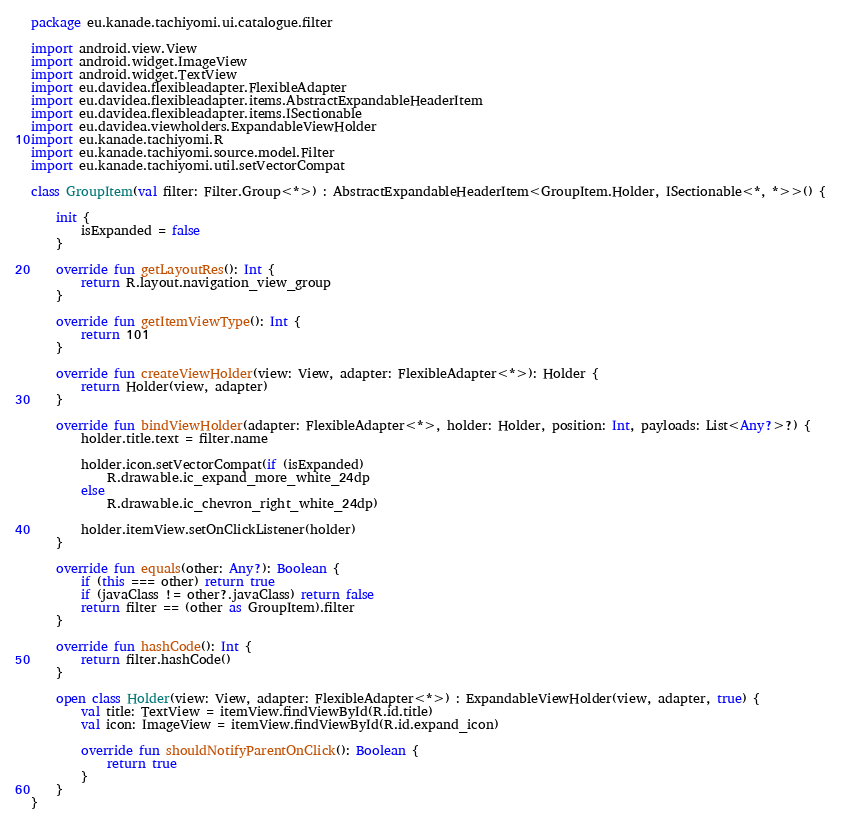<code> <loc_0><loc_0><loc_500><loc_500><_Kotlin_>package eu.kanade.tachiyomi.ui.catalogue.filter

import android.view.View
import android.widget.ImageView
import android.widget.TextView
import eu.davidea.flexibleadapter.FlexibleAdapter
import eu.davidea.flexibleadapter.items.AbstractExpandableHeaderItem
import eu.davidea.flexibleadapter.items.ISectionable
import eu.davidea.viewholders.ExpandableViewHolder
import eu.kanade.tachiyomi.R
import eu.kanade.tachiyomi.source.model.Filter
import eu.kanade.tachiyomi.util.setVectorCompat

class GroupItem(val filter: Filter.Group<*>) : AbstractExpandableHeaderItem<GroupItem.Holder, ISectionable<*, *>>() {

    init {
        isExpanded = false
    }

    override fun getLayoutRes(): Int {
        return R.layout.navigation_view_group
    }

    override fun getItemViewType(): Int {
        return 101
    }

    override fun createViewHolder(view: View, adapter: FlexibleAdapter<*>): Holder {
        return Holder(view, adapter)
    }

    override fun bindViewHolder(adapter: FlexibleAdapter<*>, holder: Holder, position: Int, payloads: List<Any?>?) {
        holder.title.text = filter.name

        holder.icon.setVectorCompat(if (isExpanded)
            R.drawable.ic_expand_more_white_24dp
        else
            R.drawable.ic_chevron_right_white_24dp)

        holder.itemView.setOnClickListener(holder)
    }

    override fun equals(other: Any?): Boolean {
        if (this === other) return true
        if (javaClass != other?.javaClass) return false
        return filter == (other as GroupItem).filter
    }

    override fun hashCode(): Int {
        return filter.hashCode()
    }

    open class Holder(view: View, adapter: FlexibleAdapter<*>) : ExpandableViewHolder(view, adapter, true) {
        val title: TextView = itemView.findViewById(R.id.title)
        val icon: ImageView = itemView.findViewById(R.id.expand_icon)

        override fun shouldNotifyParentOnClick(): Boolean {
            return true
        }
    }
}</code> 